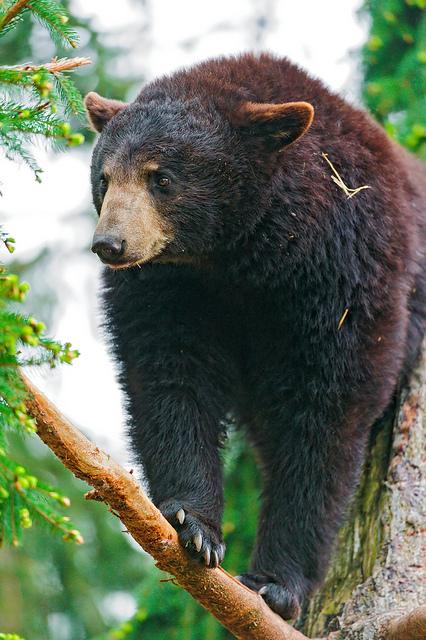Where is the bear looking?
Keep it brief. Left. Is this a young or old animal?
Keep it brief. Old. What type of bear is this?
Answer briefly. Brown. Is there a tree in the image?
Keep it brief. Yes. 